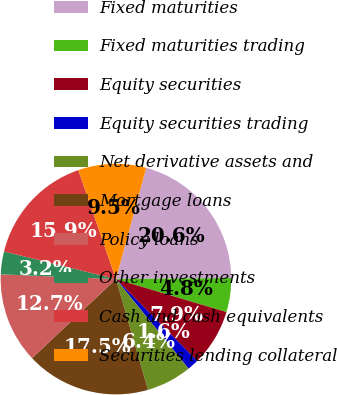Convert chart to OTSL. <chart><loc_0><loc_0><loc_500><loc_500><pie_chart><fcel>Fixed maturities<fcel>Fixed maturities trading<fcel>Equity securities<fcel>Equity securities trading<fcel>Net derivative assets and<fcel>Mortgage loans<fcel>Policy loans<fcel>Other investments<fcel>Cash and cash equivalents<fcel>Securities lending collateral<nl><fcel>20.62%<fcel>4.77%<fcel>7.94%<fcel>1.6%<fcel>6.36%<fcel>17.45%<fcel>12.69%<fcel>3.19%<fcel>15.86%<fcel>9.52%<nl></chart> 